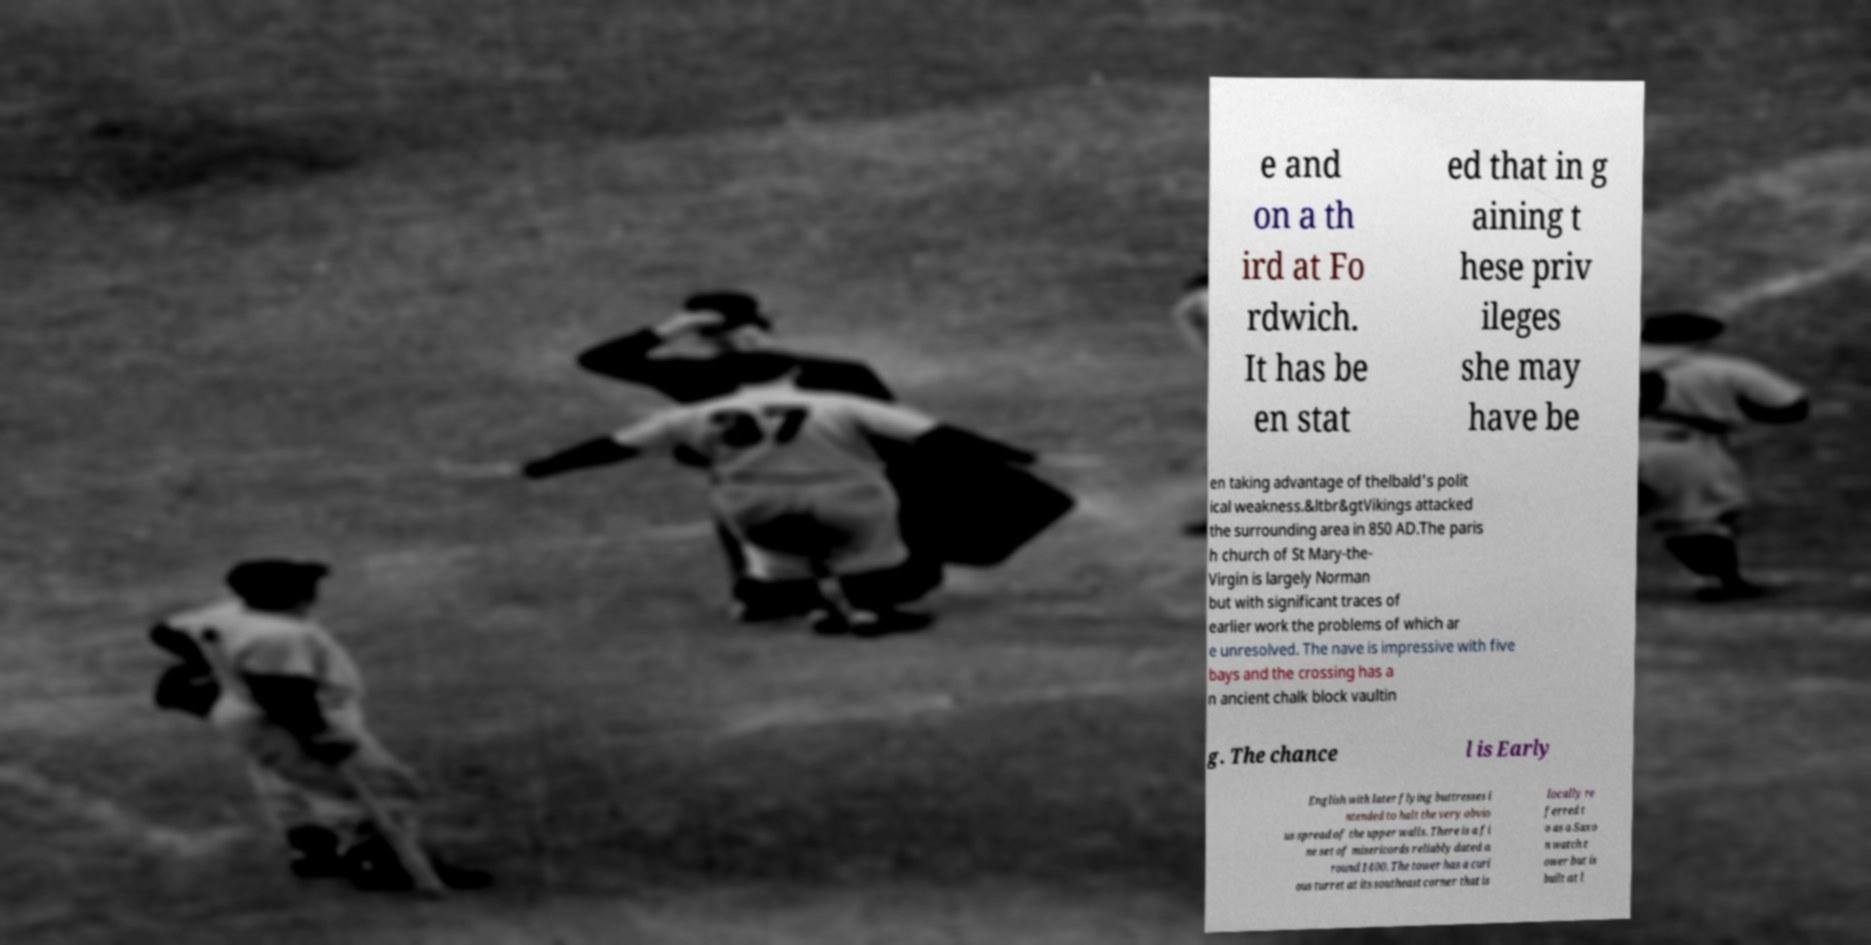Could you extract and type out the text from this image? e and on a th ird at Fo rdwich. It has be en stat ed that in g aining t hese priv ileges she may have be en taking advantage of thelbald's polit ical weakness.&ltbr&gtVikings attacked the surrounding area in 850 AD.The paris h church of St Mary-the- Virgin is largely Norman but with significant traces of earlier work the problems of which ar e unresolved. The nave is impressive with five bays and the crossing has a n ancient chalk block vaultin g. The chance l is Early English with later flying buttresses i ntended to halt the very obvio us spread of the upper walls. There is a fi ne set of misericords reliably dated a round 1400. The tower has a curi ous turret at its southeast corner that is locally re ferred t o as a Saxo n watch t ower but is built at l 